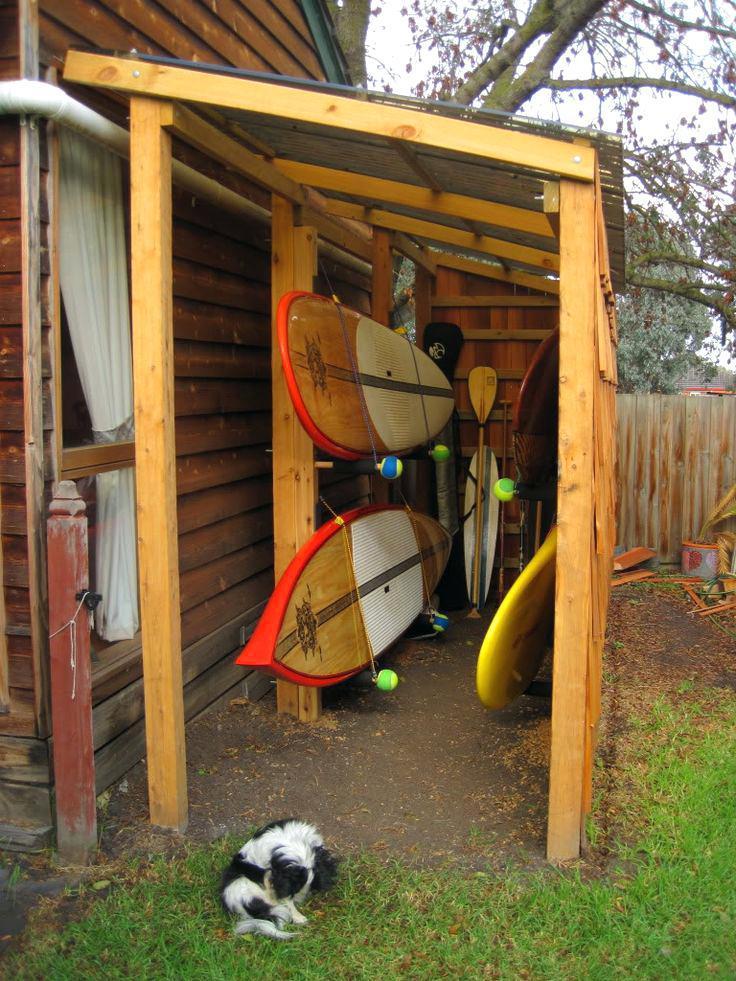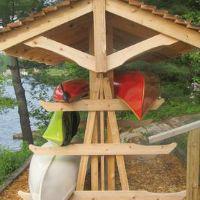The first image is the image on the left, the second image is the image on the right. Examine the images to the left and right. Is the description "there are two boats in the image pair" accurate? Answer yes or no. No. The first image is the image on the left, the second image is the image on the right. Assess this claim about the two images: "There is at least one boat in storage.". Correct or not? Answer yes or no. Yes. 